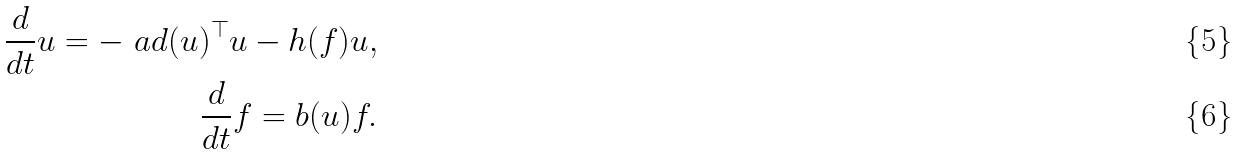Convert formula to latex. <formula><loc_0><loc_0><loc_500><loc_500>\frac { d } { d t } u = - \ a d ( u ) ^ { \top } u - h ( f ) u , \\ \frac { d } { d t } f = b ( u ) f .</formula> 